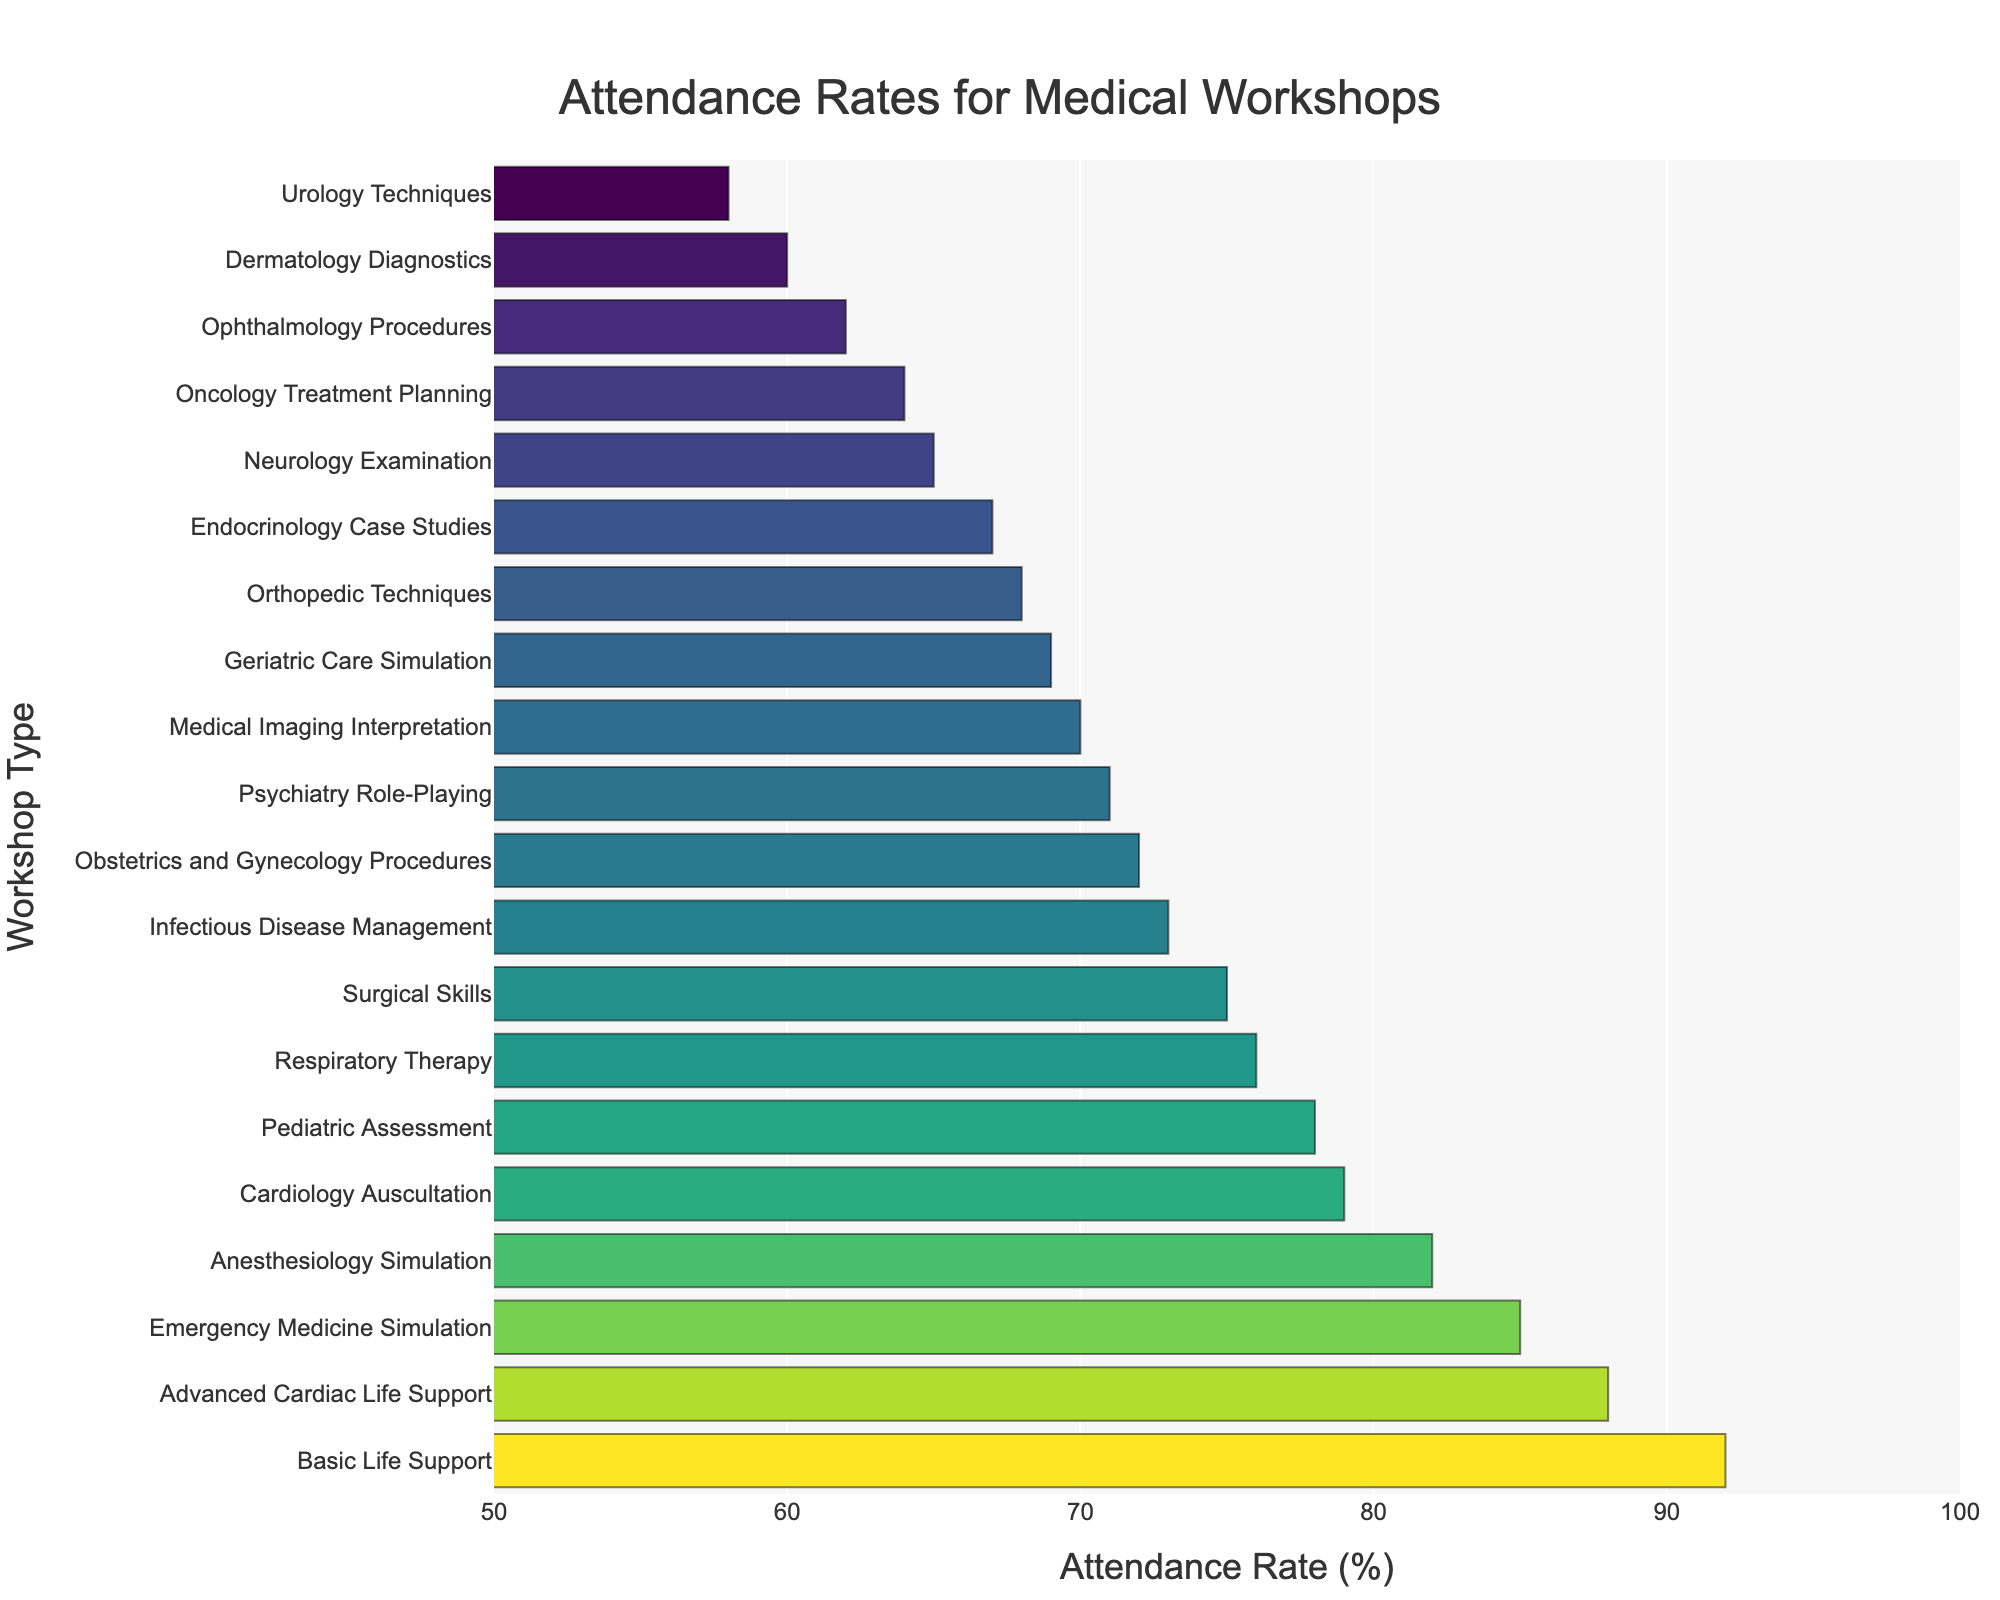What is the attendance rate for the Pediatric Assessment workshop? The Pediatric Assessment workshop is listed in the figure. By locating its corresponding bar, we see that the value is 78%.
Answer: 78 Which workshop has the highest attendance rate? By observing the lengths of the bars, the Basic Life Support workshop has the highest attendance rate at 92%.
Answer: Basic Life Support How does the attendance rate for the Surgical Skills workshop compare with the Medical Imaging Interpretation workshop? The Surgical Skills workshop has an attendance rate of 75%, while the Medical Imaging Interpretation workshop has an attendance rate of 70%. 75% is greater than 70%.
Answer: Higher What is the combined attendance rate for the top three workshops? The top three workshops are Basic Life Support, Advanced Cardiac Life Support, and Anesthesiology Simulation with rates of 92%, 88%, and 85%, respectively. Summing these rates: 92 + 88 + 85 = 265%.
Answer: 265% What's the average attendance rate of the workshops with rates below 70%? Workshops below 70% are Neurology Examination (65%), Dermatology Diagnostics (60%), Orthopedic Techniques (68%), Endocrinology Case Studies (67%), Ophthalmology Procedures (62%), Geriatric Care Simulation (69%), Oncology Treatment Planning (64%), and Urology Techniques (58%).
Sum: 65 + 60 + 68 + 67 + 62 + 69 + 64 + 58 = 513. Count: 8. Average: 513 / 8 = 64.1%
Answer: 64.1% Is the attendance rate for Psychiatry Role-Playing higher, lower, or equal to that for Infectious Disease Management? The attendance rate for Psychiatry Role-Playing is 71%, and for Infectious Disease Management, it is 73%. 71% is lower than 73%.
Answer: Lower What is the median attendance rate of all the workshops? To find the median, sort the attendance rates: [58, 60, 62, 64, 65, 67, 68, 69, 70, 71, 72, 73, 75, 76, 78, 79, 82, 85, 88, 92]. With 20 data points, the median is the average of the 10th and 11th values: (71 + 72) / 2 = 71.5%.
Answer: 71.5 Which workshops have an attendance rate that falls in the range of 60%-70%? By looking at the figure, workshops with attendance rates between 60% and 70% are:
Neurology Examination (65%), Dermatology Diagnostics (60%), Endocrinology Case Studies (67%), Orthopedic Techniques (68%), Geriatric Care Simulation (69%), and Oncology Treatment Planning (64%).
Answer: Neurology Examination, Dermatology Diagnostics, Endocrinology Case Studies, Orthopedic Techniques, Geriatric Care Simulation, Oncology Treatment Planning 